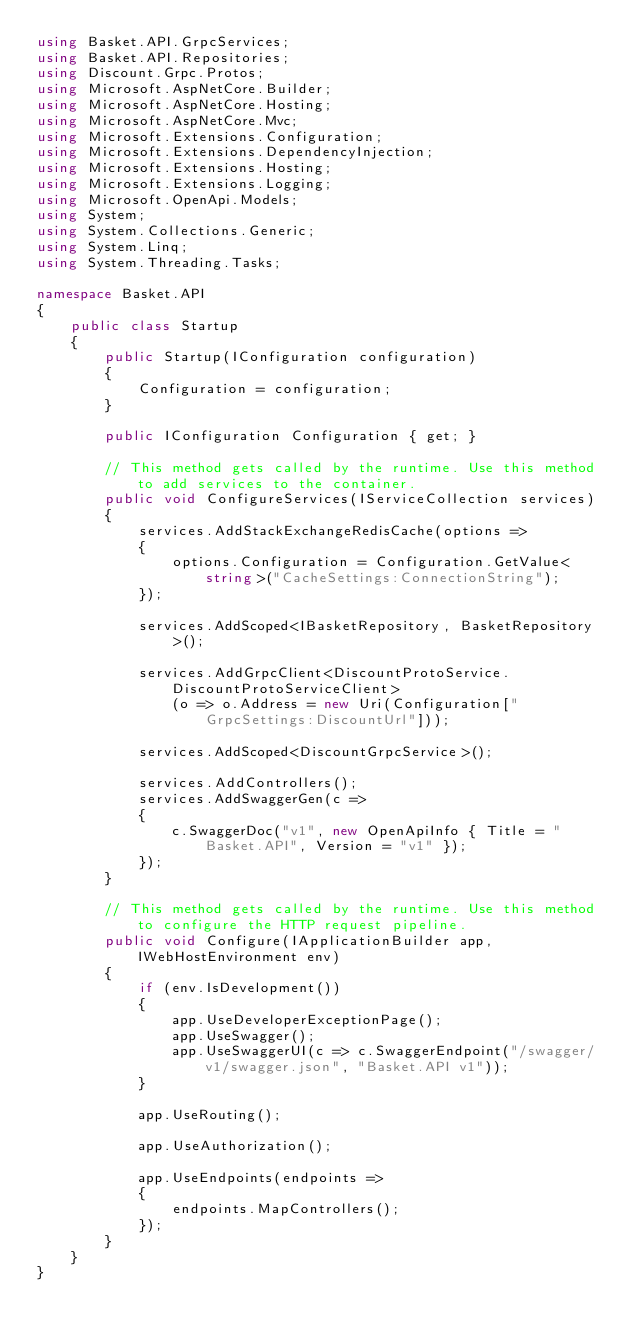Convert code to text. <code><loc_0><loc_0><loc_500><loc_500><_C#_>using Basket.API.GrpcServices;
using Basket.API.Repositories;
using Discount.Grpc.Protos;
using Microsoft.AspNetCore.Builder;
using Microsoft.AspNetCore.Hosting;
using Microsoft.AspNetCore.Mvc;
using Microsoft.Extensions.Configuration;
using Microsoft.Extensions.DependencyInjection;
using Microsoft.Extensions.Hosting;
using Microsoft.Extensions.Logging;
using Microsoft.OpenApi.Models;
using System;
using System.Collections.Generic;
using System.Linq;
using System.Threading.Tasks;

namespace Basket.API
{
    public class Startup
    {
        public Startup(IConfiguration configuration)
        {
            Configuration = configuration;
        }

        public IConfiguration Configuration { get; }

        // This method gets called by the runtime. Use this method to add services to the container.
        public void ConfigureServices(IServiceCollection services)
        {
            services.AddStackExchangeRedisCache(options => 
            {
                options.Configuration = Configuration.GetValue<string>("CacheSettings:ConnectionString");
            });

            services.AddScoped<IBasketRepository, BasketRepository>();

            services.AddGrpcClient<DiscountProtoService.DiscountProtoServiceClient>
                (o => o.Address = new Uri(Configuration["GrpcSettings:DiscountUrl"]));

            services.AddScoped<DiscountGrpcService>();

            services.AddControllers();
            services.AddSwaggerGen(c =>
            {
                c.SwaggerDoc("v1", new OpenApiInfo { Title = "Basket.API", Version = "v1" });
            });
        }

        // This method gets called by the runtime. Use this method to configure the HTTP request pipeline.
        public void Configure(IApplicationBuilder app, IWebHostEnvironment env)
        {
            if (env.IsDevelopment())
            {
                app.UseDeveloperExceptionPage();
                app.UseSwagger();
                app.UseSwaggerUI(c => c.SwaggerEndpoint("/swagger/v1/swagger.json", "Basket.API v1"));
            }

            app.UseRouting();

            app.UseAuthorization();

            app.UseEndpoints(endpoints =>
            {
                endpoints.MapControllers();
            });
        }
    }
}
</code> 